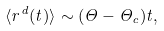Convert formula to latex. <formula><loc_0><loc_0><loc_500><loc_500>\langle r ^ { d } ( t ) \rangle \sim ( \Theta - \Theta _ { c } ) t ,</formula> 